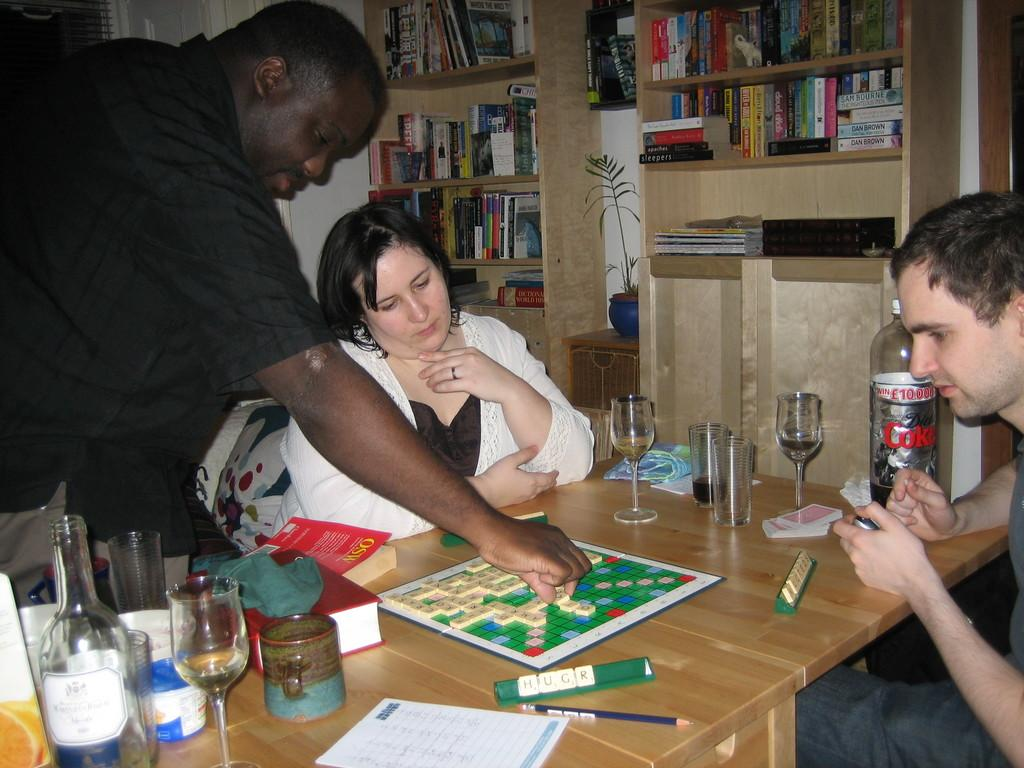How many people are in the image? There are three people in the image. Can you describe the position of one of the people? One of the people is a woman, and she is sitting. What objects can be seen on the table in the image? On the table, there is a glass, a bottle, a book, a cloth, a board, a paper, a pencil, and cards. What other items are present in the image? There is a book rack and a flower pot in the image. How does the train move through the image? There is no train present in the image. Can you describe the suit that the woman is wearing in the image? The woman is not wearing a suit in the image; she is wearing a dress. 